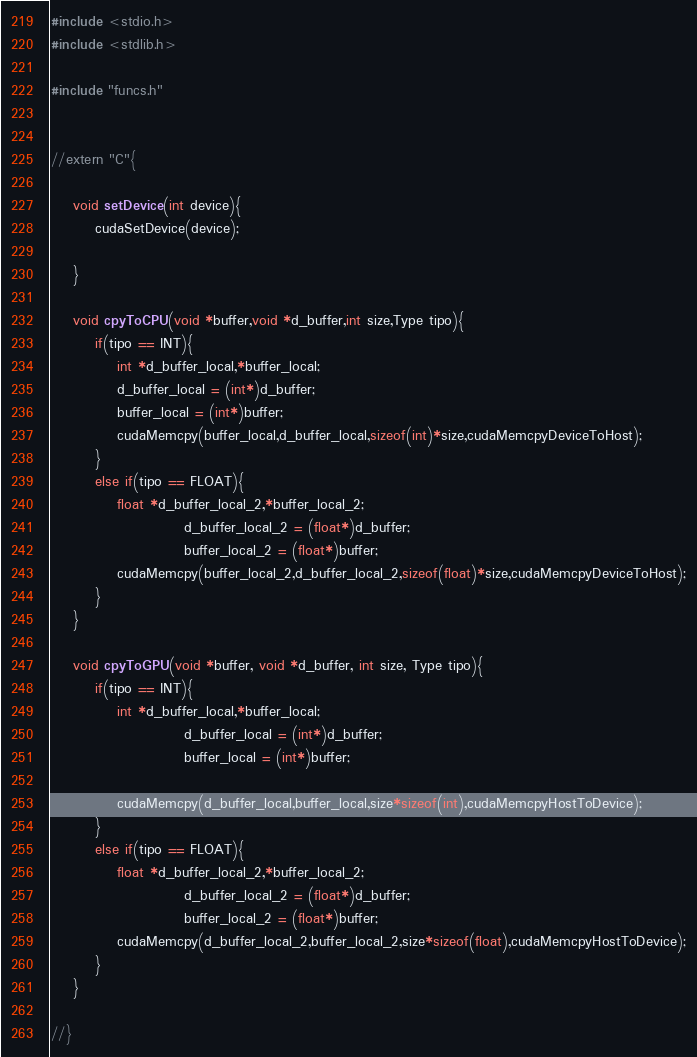Convert code to text. <code><loc_0><loc_0><loc_500><loc_500><_Cuda_>#include <stdio.h>
#include <stdlib.h>

#include "funcs.h"


//extern "C"{

	void setDevice(int device){
		cudaSetDevice(device);
		
	}

	void cpyToCPU(void *buffer,void *d_buffer,int size,Type tipo){
		if(tipo == INT){
			int *d_buffer_local,*buffer_local;
			d_buffer_local = (int*)d_buffer;
			buffer_local = (int*)buffer;
			cudaMemcpy(buffer_local,d_buffer_local,sizeof(int)*size,cudaMemcpyDeviceToHost);
		}
		else if(tipo == FLOAT){
			float *d_buffer_local_2,*buffer_local_2;
                        d_buffer_local_2 = (float*)d_buffer;
                        buffer_local_2 = (float*)buffer;
			cudaMemcpy(buffer_local_2,d_buffer_local_2,sizeof(float)*size,cudaMemcpyDeviceToHost);
		}
	}

	void cpyToGPU(void *buffer, void *d_buffer, int size, Type tipo){
		if(tipo == INT){
			int *d_buffer_local,*buffer_local;
                        d_buffer_local = (int*)d_buffer;
                        buffer_local = (int*)buffer;
			
			cudaMemcpy(d_buffer_local,buffer_local,size*sizeof(int),cudaMemcpyHostToDevice);
		}
		else if(tipo == FLOAT){
			float *d_buffer_local_2,*buffer_local_2;
                        d_buffer_local_2 = (float*)d_buffer;
                        buffer_local_2 = (float*)buffer;
			cudaMemcpy(d_buffer_local_2,buffer_local_2,size*sizeof(float),cudaMemcpyHostToDevice);
		}
	}

//}
</code> 